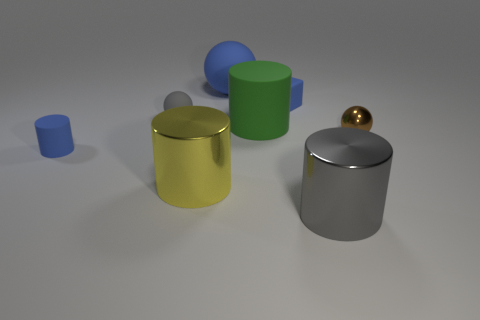Subtract 1 cylinders. How many cylinders are left? 3 Add 1 large things. How many objects exist? 9 Subtract all gray cylinders. How many cylinders are left? 3 Subtract all big green matte cylinders. How many cylinders are left? 3 Subtract all cyan cylinders. Subtract all blue spheres. How many cylinders are left? 4 Subtract all blocks. How many objects are left? 7 Subtract 1 blue spheres. How many objects are left? 7 Subtract all small gray objects. Subtract all small objects. How many objects are left? 3 Add 7 gray balls. How many gray balls are left? 8 Add 3 tiny cyan metal blocks. How many tiny cyan metal blocks exist? 3 